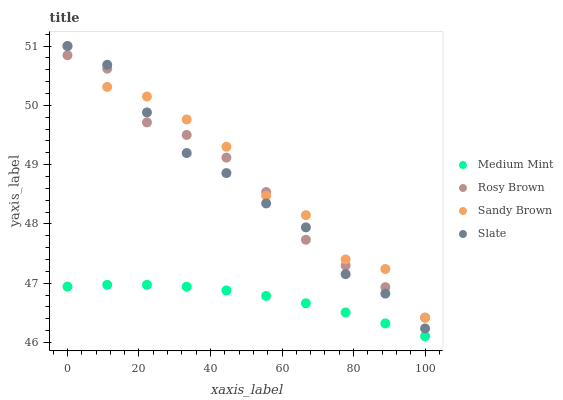Does Medium Mint have the minimum area under the curve?
Answer yes or no. Yes. Does Sandy Brown have the maximum area under the curve?
Answer yes or no. Yes. Does Slate have the minimum area under the curve?
Answer yes or no. No. Does Slate have the maximum area under the curve?
Answer yes or no. No. Is Medium Mint the smoothest?
Answer yes or no. Yes. Is Sandy Brown the roughest?
Answer yes or no. Yes. Is Slate the smoothest?
Answer yes or no. No. Is Slate the roughest?
Answer yes or no. No. Does Medium Mint have the lowest value?
Answer yes or no. Yes. Does Slate have the lowest value?
Answer yes or no. No. Does Sandy Brown have the highest value?
Answer yes or no. Yes. Does Rosy Brown have the highest value?
Answer yes or no. No. Is Medium Mint less than Slate?
Answer yes or no. Yes. Is Slate greater than Medium Mint?
Answer yes or no. Yes. Does Sandy Brown intersect Rosy Brown?
Answer yes or no. Yes. Is Sandy Brown less than Rosy Brown?
Answer yes or no. No. Is Sandy Brown greater than Rosy Brown?
Answer yes or no. No. Does Medium Mint intersect Slate?
Answer yes or no. No. 